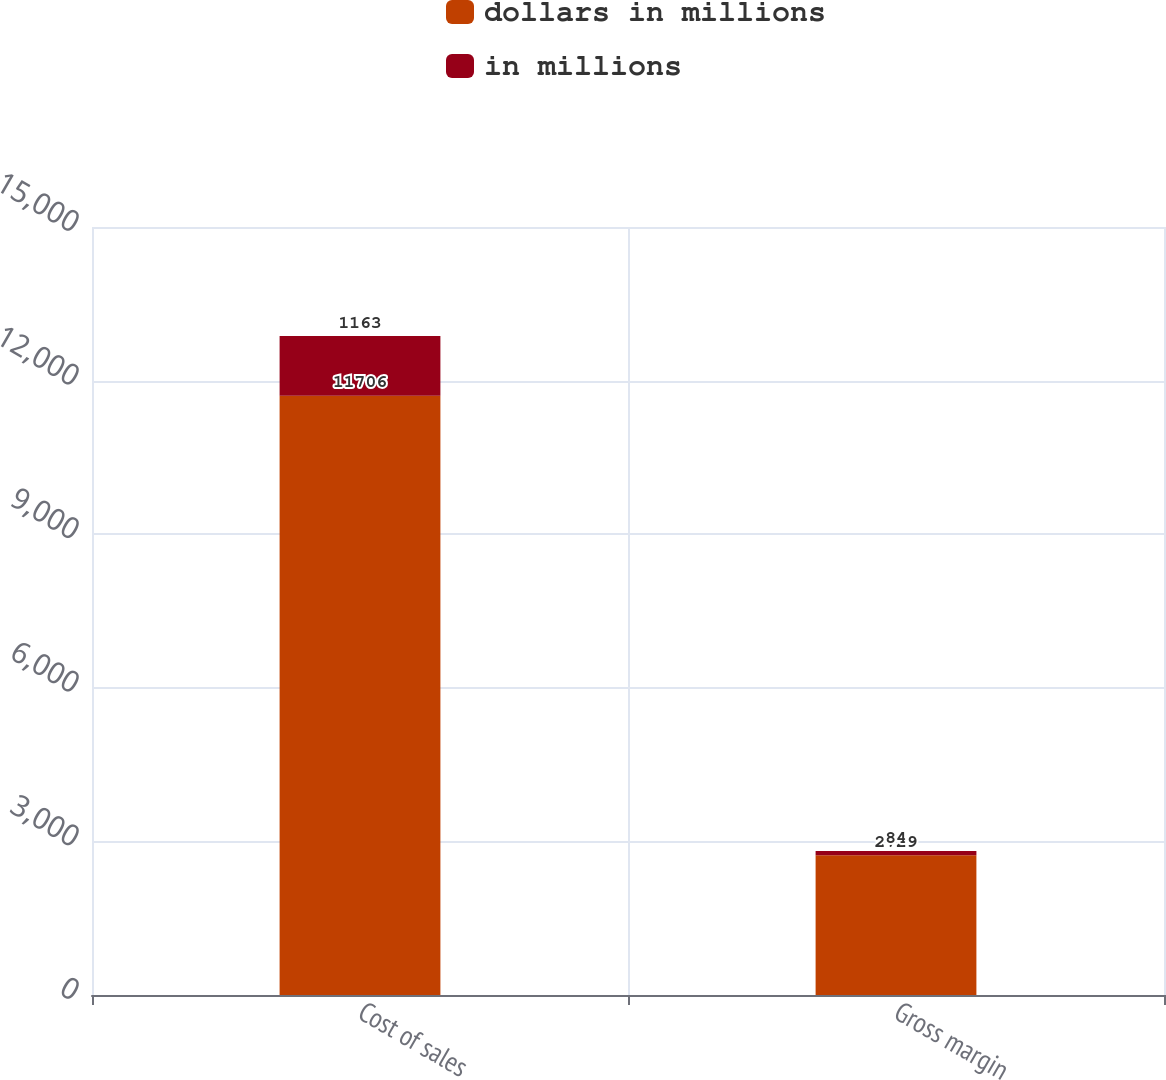Convert chart. <chart><loc_0><loc_0><loc_500><loc_500><stacked_bar_chart><ecel><fcel>Cost of sales<fcel>Gross margin<nl><fcel>dollars in millions<fcel>11706<fcel>2729<nl><fcel>in millions<fcel>1163<fcel>84<nl></chart> 